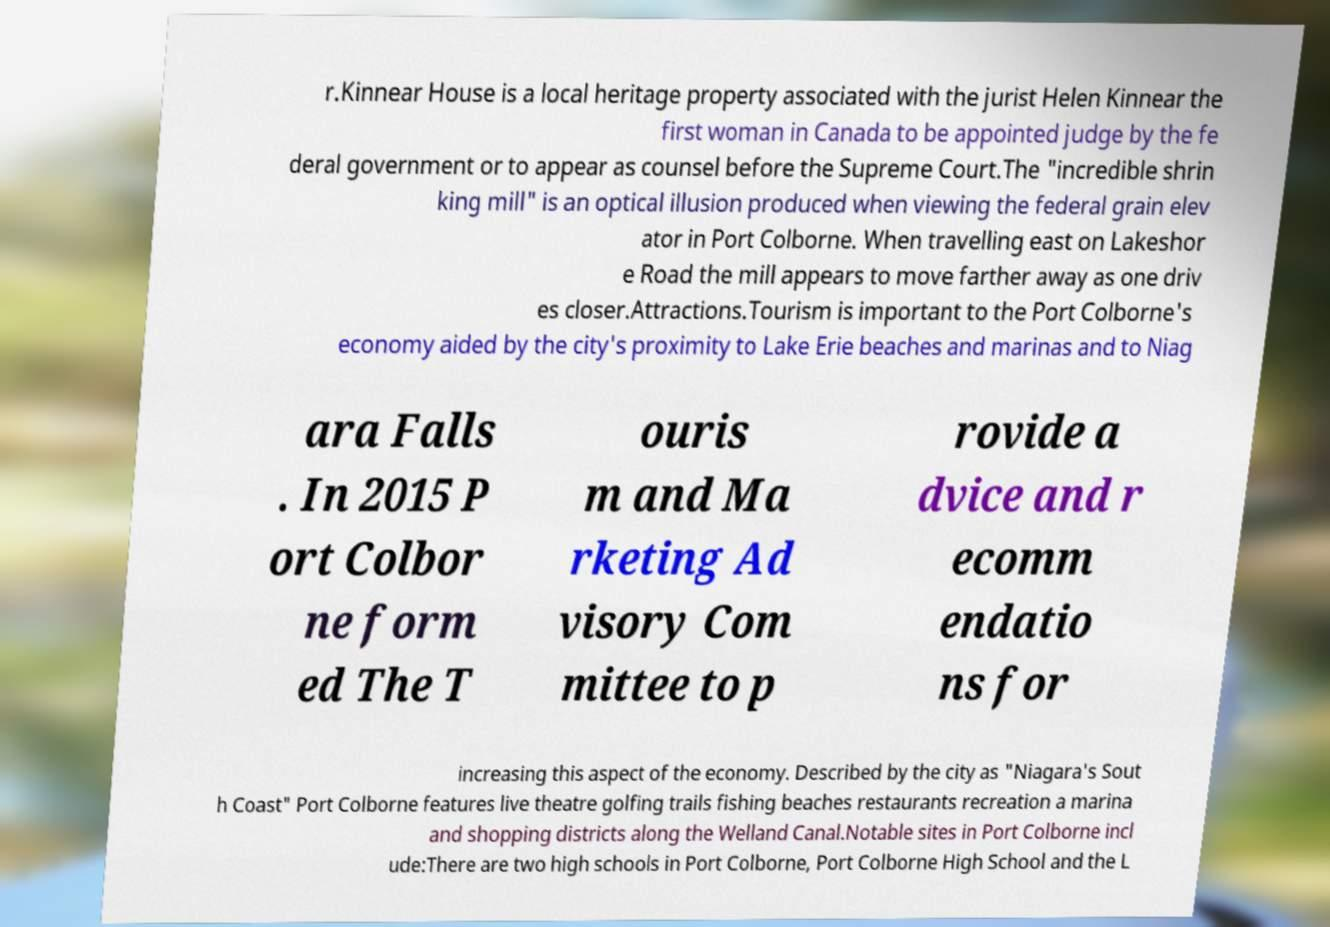Please identify and transcribe the text found in this image. r.Kinnear House is a local heritage property associated with the jurist Helen Kinnear the first woman in Canada to be appointed judge by the fe deral government or to appear as counsel before the Supreme Court.The "incredible shrin king mill" is an optical illusion produced when viewing the federal grain elev ator in Port Colborne. When travelling east on Lakeshor e Road the mill appears to move farther away as one driv es closer.Attractions.Tourism is important to the Port Colborne's economy aided by the city's proximity to Lake Erie beaches and marinas and to Niag ara Falls . In 2015 P ort Colbor ne form ed The T ouris m and Ma rketing Ad visory Com mittee to p rovide a dvice and r ecomm endatio ns for increasing this aspect of the economy. Described by the city as "Niagara's Sout h Coast" Port Colborne features live theatre golfing trails fishing beaches restaurants recreation a marina and shopping districts along the Welland Canal.Notable sites in Port Colborne incl ude:There are two high schools in Port Colborne, Port Colborne High School and the L 